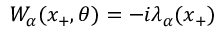Convert formula to latex. <formula><loc_0><loc_0><loc_500><loc_500>W _ { \alpha } ( x _ { + } , \theta ) = - i \lambda _ { \alpha } ( x _ { + } )</formula> 